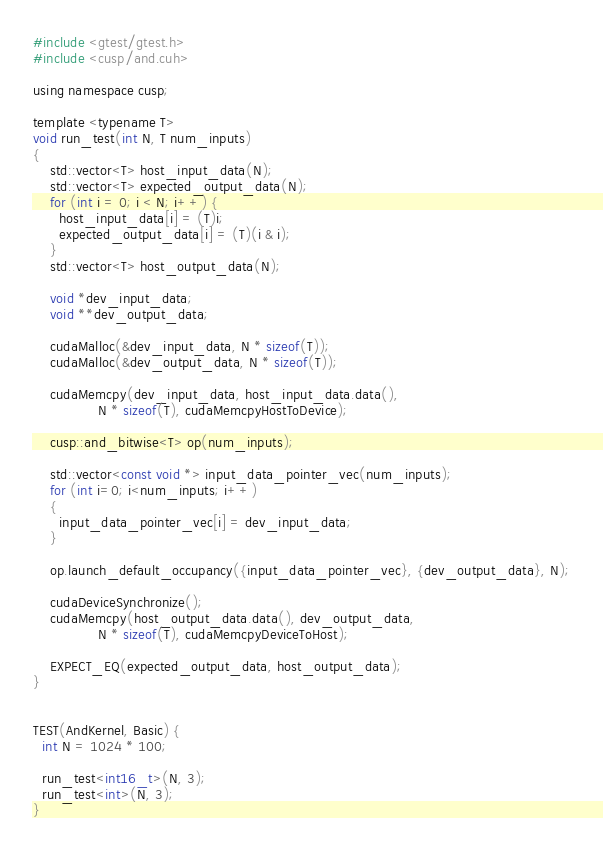Convert code to text. <code><loc_0><loc_0><loc_500><loc_500><_Cuda_>#include <gtest/gtest.h>
#include <cusp/and.cuh>

using namespace cusp;

template <typename T> 
void run_test(int N, T num_inputs)
{
    std::vector<T> host_input_data(N);
    std::vector<T> expected_output_data(N);
    for (int i = 0; i < N; i++) {
      host_input_data[i] = (T)i;
      expected_output_data[i] = (T)(i & i);
    }
    std::vector<T> host_output_data(N);
  
    void *dev_input_data;
    void **dev_output_data;
  
    cudaMalloc(&dev_input_data, N * sizeof(T));
    cudaMalloc(&dev_output_data, N * sizeof(T));

    cudaMemcpy(dev_input_data, host_input_data.data(),
               N * sizeof(T), cudaMemcpyHostToDevice);
  
    cusp::and_bitwise<T> op(num_inputs);

    std::vector<const void *> input_data_pointer_vec(num_inputs);
    for (int i=0; i<num_inputs; i++)
    {
      input_data_pointer_vec[i] = dev_input_data;
    }

    op.launch_default_occupancy({input_data_pointer_vec}, {dev_output_data}, N);
  
    cudaDeviceSynchronize();
    cudaMemcpy(host_output_data.data(), dev_output_data,
               N * sizeof(T), cudaMemcpyDeviceToHost);
  
    EXPECT_EQ(expected_output_data, host_output_data);
}


TEST(AndKernel, Basic) {
  int N = 1024 * 100;

  run_test<int16_t>(N, 3);
  run_test<int>(N, 3);
}</code> 